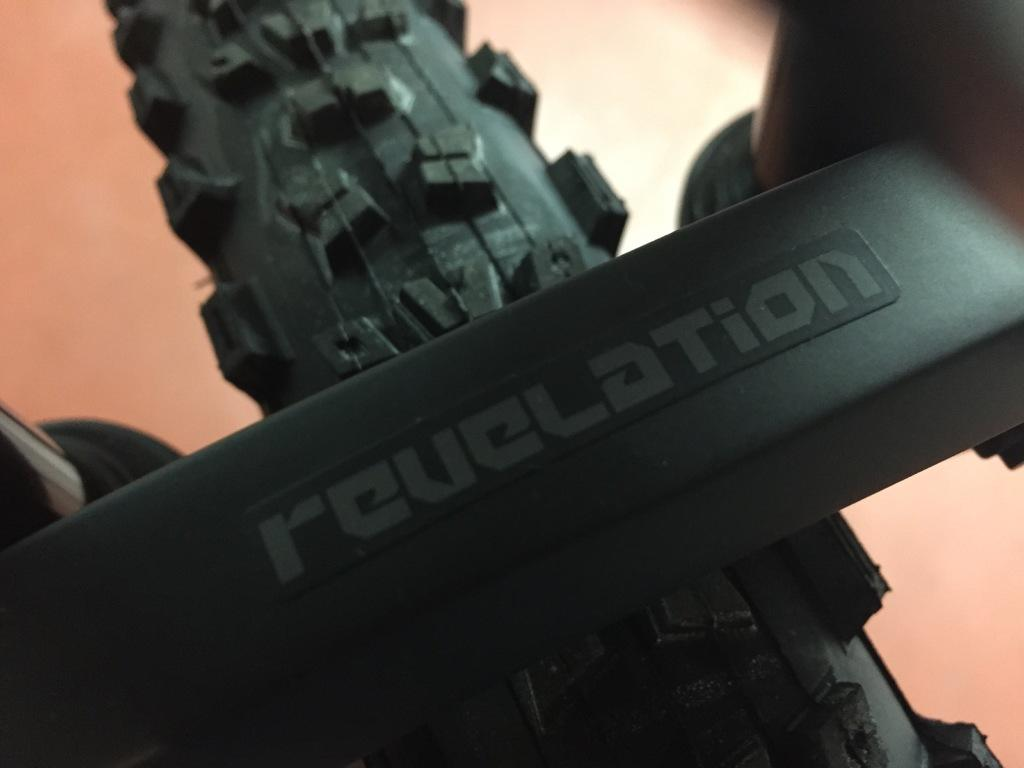What is the main focus of the image? The main focus of the image is a bicycle tire. Can you describe the subject of the image in more detail? The image is a zoomed-in picture of a bicycle tire. What type of wire can be seen connected to the bicycle tire in the image? There is no wire connected to the bicycle tire in the image. How does the bicycle tire contribute to pollution in the image? The image does not show any pollution or its effects, and the bicycle tire itself does not contribute to pollution. Is there a throne visible in the image? There is no throne present in the image; it only features a bicycle tire. 